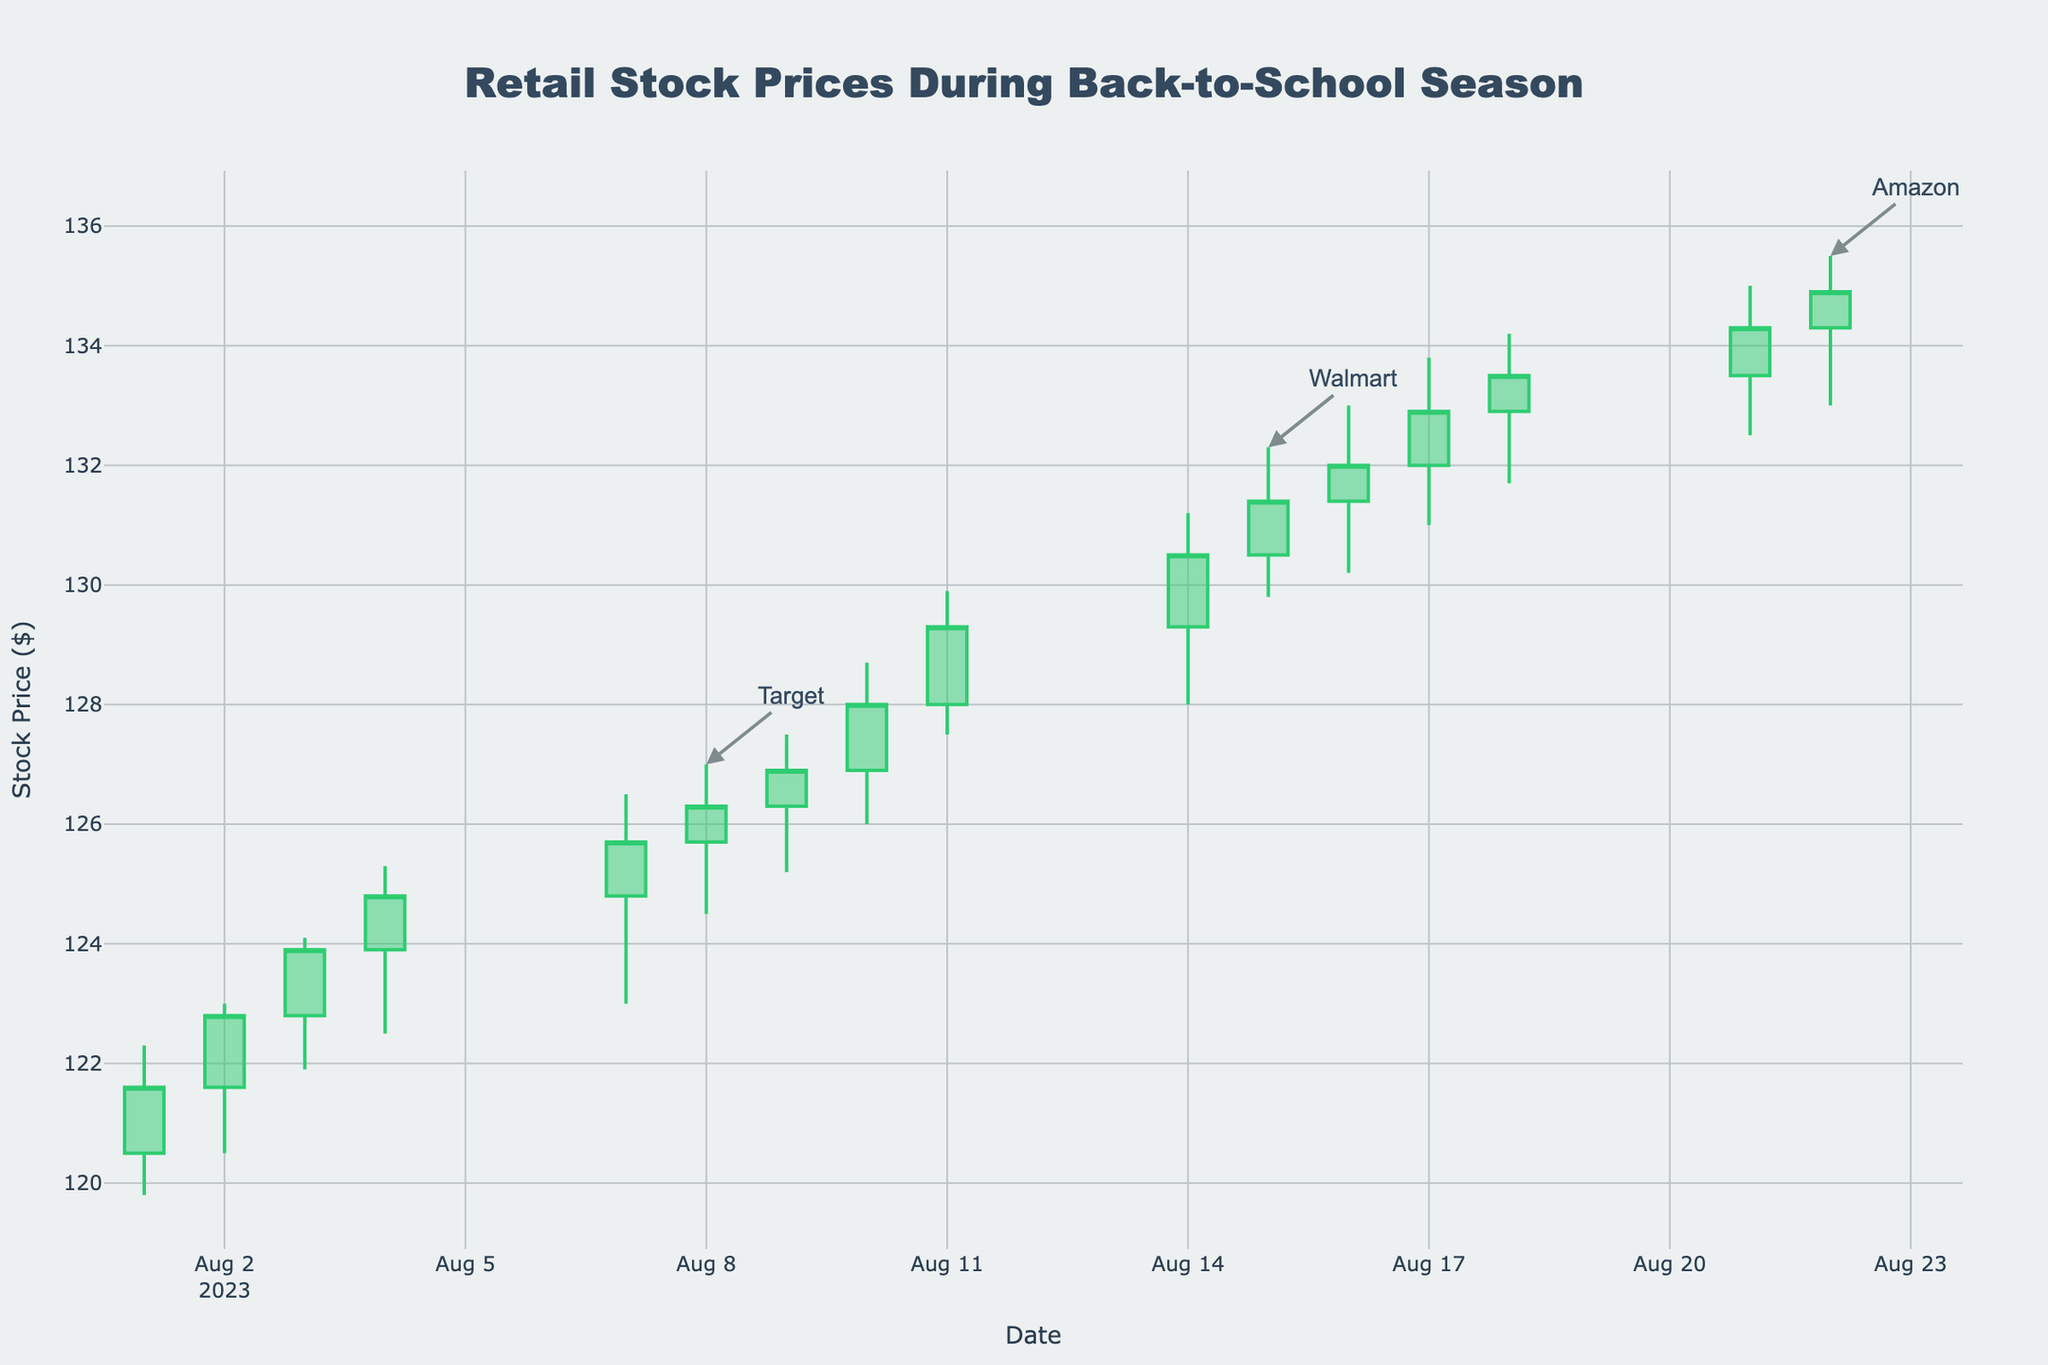what is the title of the plot? The title of the plot can be found at the top center of the figure. In this case, it states "Retail Stock Prices During Back-to-School Season"
Answer: Retail Stock Prices During Back-to-School Season how many companies are represented in the plot? Each unique company has annotations at the end of their data points. By counting these annotations, we see three companies: Target, Walmart, and Amazon
Answer: 3 what is the color of the lines indicating an increase in stock price? The color of the lines indicating an increase in stock price can be identified by looking at the candlestick charts. The increasing line color is green
Answer: green on which date did Target have the highest stock price? Check the date when Target's stock had the highest "High" value on the candlestick chart. Target's highest stock price is visible on August 08, 2023
Answer: August 08, 2023 what's the trend in stock prices for Walmart between August 9 and August 15? To understand Walmart's trend, observe the candlestick patterns between these dates. The closing prices generally increase, indicating an upward trend
Answer: upward trend which company had the highest recorded stock price during the period? The highest recorded stock price is where the high value is the maximum. By comparing all companies' high points, Amazon on August 21, 2023 had the highest at $135.00
Answer: Amazon by how much did Amazon's stock price increase from August 16 to August 22? Calculate the difference in Amazon's closing prices on these dates. The closing price on August 16 is $132.00 and on August 22 is $134.90. The increase is $134.90 - $132.00 = $2.90
Answer: $2.90 which day had the highest single-day trading volume and which company does it belong to? Observe the volume of trades; the day with the highest bar indicates the highest volume. The highest single-day trading volume is for Walmart on August 14, 2023
Answer: Walmart on August 14, 2023 compare the stock price patterns of Target and Walmart in terms of general trend and volatility For comparison, observe the closing prices and candlestick heights of both companies. Target shows a generally upward trend with moderate volatility; Walmart has a slightly more volatile upward trend
Answer: Target: moderate upward trend, Walmart: volatile upward trend 